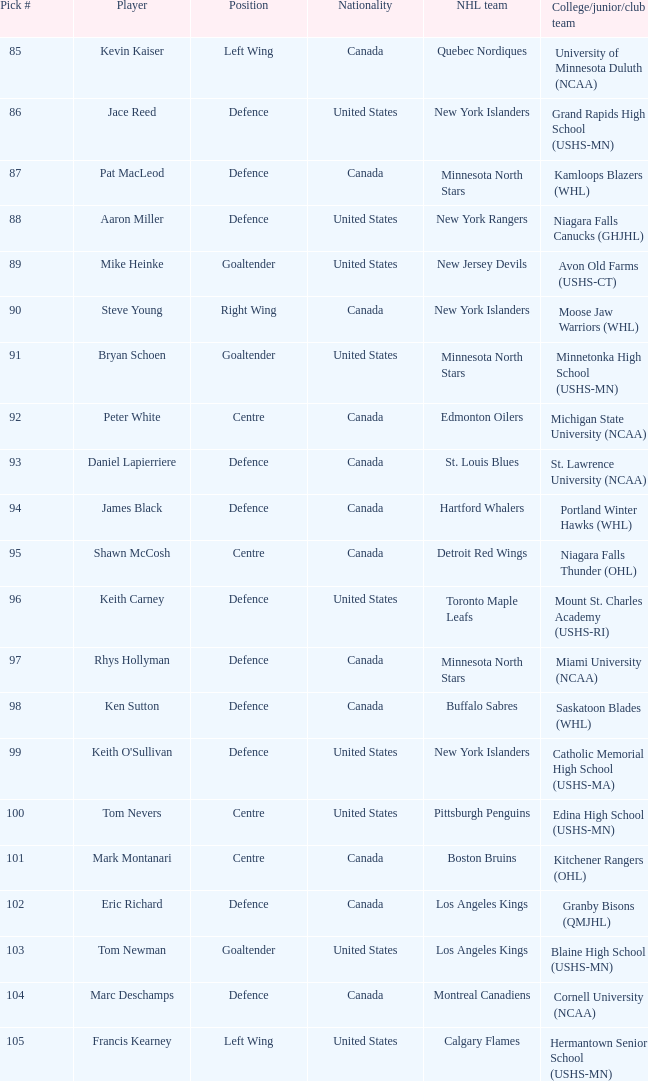What position did the #94 pick play? Defence. 